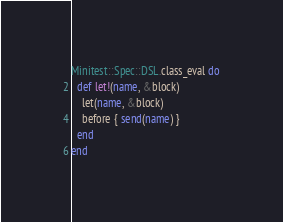<code> <loc_0><loc_0><loc_500><loc_500><_Ruby_>Minitest::Spec::DSL.class_eval do
  def let!(name, &block)
    let(name, &block)
    before { send(name) }
  end
end
</code> 